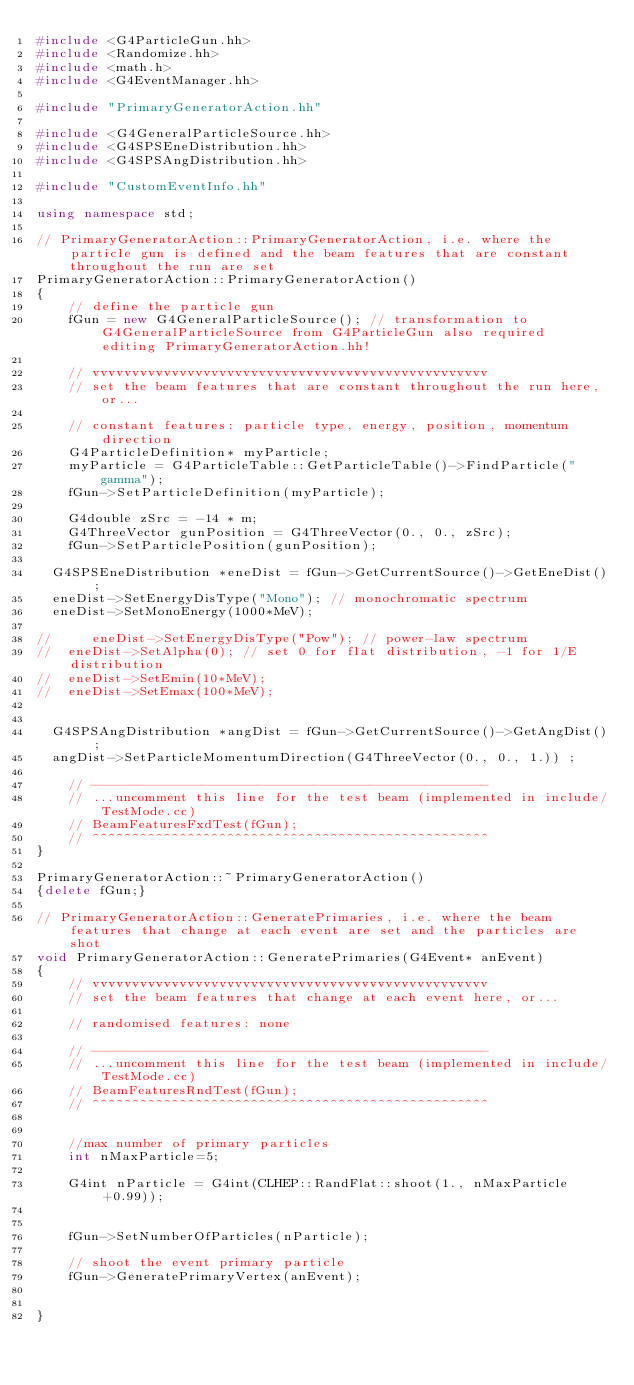<code> <loc_0><loc_0><loc_500><loc_500><_C++_>#include <G4ParticleGun.hh>
#include <Randomize.hh>
#include <math.h>
#include <G4EventManager.hh>

#include "PrimaryGeneratorAction.hh"

#include <G4GeneralParticleSource.hh>
#include <G4SPSEneDistribution.hh>
#include <G4SPSAngDistribution.hh>

#include "CustomEventInfo.hh"

using namespace std;

// PrimaryGeneratorAction::PrimaryGeneratorAction, i.e. where the particle gun is defined and the beam features that are constant throughout the run are set
PrimaryGeneratorAction::PrimaryGeneratorAction()
{
    // define the particle gun
    fGun = new G4GeneralParticleSource(); // transformation to G4GeneralParticleSource from G4ParticleGun also required editing PrimaryGeneratorAction.hh!
	
    // vvvvvvvvvvvvvvvvvvvvvvvvvvvvvvvvvvvvvvvvvvvvvvvvvv
    // set the beam features that are constant throughout the run here, or...
    
    // constant features: particle type, energy, position, momentum direction
    G4ParticleDefinition* myParticle;
    myParticle = G4ParticleTable::GetParticleTable()->FindParticle("gamma");
    fGun->SetParticleDefinition(myParticle);
	
    G4double zSrc = -14 * m;
    G4ThreeVector gunPosition = G4ThreeVector(0., 0., zSrc);
    fGun->SetParticlePosition(gunPosition);
	
	G4SPSEneDistribution *eneDist = fGun->GetCurrentSource()->GetEneDist() ;
	eneDist->SetEnergyDisType("Mono"); // monochromatic spectrum
	eneDist->SetMonoEnergy(1000*MeV);
	
//     eneDist->SetEnergyDisType("Pow"); // power-law spectrum
// 	eneDist->SetAlpha(0); // set 0 for flat distribution, -1 for 1/E distribution
// 	eneDist->SetEmin(10*MeV);
// 	eneDist->SetEmax(100*MeV);

    
	G4SPSAngDistribution *angDist = fGun->GetCurrentSource()->GetAngDist() ;
	angDist->SetParticleMomentumDirection(G4ThreeVector(0., 0., 1.)) ;

    // --------------------------------------------------
    // ...uncomment this line for the test beam (implemented in include/TestMode.cc)
    // BeamFeaturesFxdTest(fGun);
    // ^^^^^^^^^^^^^^^^^^^^^^^^^^^^^^^^^^^^^^^^^^^^^^^^^^
}

PrimaryGeneratorAction::~PrimaryGeneratorAction()
{delete fGun;}

// PrimaryGeneratorAction::GeneratePrimaries, i.e. where the beam features that change at each event are set and the particles are shot
void PrimaryGeneratorAction::GeneratePrimaries(G4Event* anEvent)
{
    // vvvvvvvvvvvvvvvvvvvvvvvvvvvvvvvvvvvvvvvvvvvvvvvvvv
    // set the beam features that change at each event here, or...
    
    // randomised features: none

    // --------------------------------------------------
    // ...uncomment this line for the test beam (implemented in include/TestMode.cc)
    // BeamFeaturesRndTest(fGun);
    // ^^^^^^^^^^^^^^^^^^^^^^^^^^^^^^^^^^^^^^^^^^^^^^^^^^
	
    
    //max number of primary particles
    int nMaxParticle=5;
    
    G4int nParticle = G4int(CLHEP::RandFlat::shoot(1., nMaxParticle+0.99));
    
    
    fGun->SetNumberOfParticles(nParticle);
    
    // shoot the event primary particle
    fGun->GeneratePrimaryVertex(anEvent);
    
    
}
</code> 